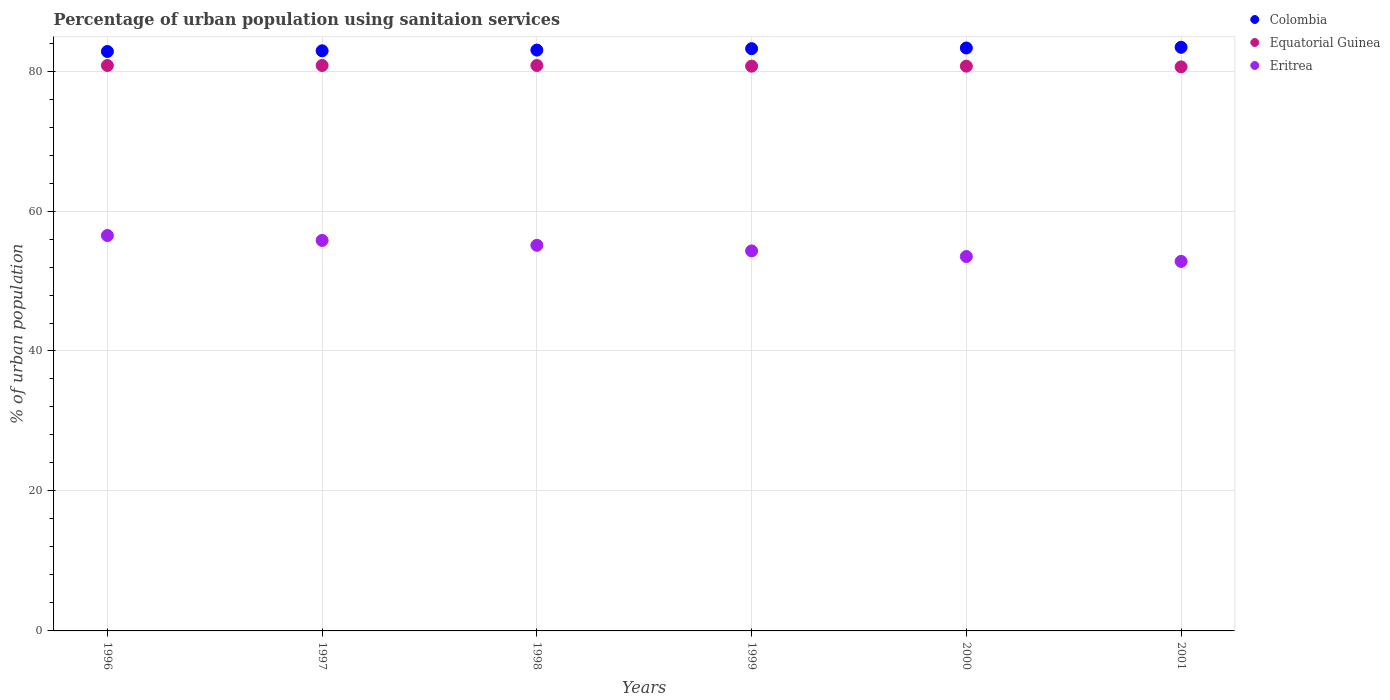How many different coloured dotlines are there?
Offer a terse response. 3. What is the percentage of urban population using sanitaion services in Eritrea in 1998?
Provide a short and direct response. 55.1. Across all years, what is the maximum percentage of urban population using sanitaion services in Eritrea?
Make the answer very short. 56.5. Across all years, what is the minimum percentage of urban population using sanitaion services in Eritrea?
Your response must be concise. 52.8. In which year was the percentage of urban population using sanitaion services in Equatorial Guinea maximum?
Make the answer very short. 1996. What is the total percentage of urban population using sanitaion services in Equatorial Guinea in the graph?
Make the answer very short. 484.4. What is the difference between the percentage of urban population using sanitaion services in Colombia in 1998 and that in 2001?
Give a very brief answer. -0.4. What is the difference between the percentage of urban population using sanitaion services in Equatorial Guinea in 1998 and the percentage of urban population using sanitaion services in Eritrea in 1996?
Your answer should be compact. 24.3. What is the average percentage of urban population using sanitaion services in Equatorial Guinea per year?
Your response must be concise. 80.73. In the year 1998, what is the difference between the percentage of urban population using sanitaion services in Equatorial Guinea and percentage of urban population using sanitaion services in Colombia?
Provide a short and direct response. -2.2. In how many years, is the percentage of urban population using sanitaion services in Colombia greater than 64 %?
Offer a very short reply. 6. What is the ratio of the percentage of urban population using sanitaion services in Colombia in 1996 to that in 2001?
Your answer should be compact. 0.99. What is the difference between the highest and the second highest percentage of urban population using sanitaion services in Eritrea?
Provide a succinct answer. 0.7. What is the difference between the highest and the lowest percentage of urban population using sanitaion services in Equatorial Guinea?
Ensure brevity in your answer.  0.2. In how many years, is the percentage of urban population using sanitaion services in Colombia greater than the average percentage of urban population using sanitaion services in Colombia taken over all years?
Provide a succinct answer. 3. Is the sum of the percentage of urban population using sanitaion services in Colombia in 1998 and 1999 greater than the maximum percentage of urban population using sanitaion services in Equatorial Guinea across all years?
Ensure brevity in your answer.  Yes. Is the percentage of urban population using sanitaion services in Colombia strictly greater than the percentage of urban population using sanitaion services in Eritrea over the years?
Offer a very short reply. Yes. How many dotlines are there?
Your answer should be compact. 3. What is the difference between two consecutive major ticks on the Y-axis?
Provide a succinct answer. 20. Does the graph contain any zero values?
Provide a short and direct response. No. Does the graph contain grids?
Ensure brevity in your answer.  Yes. Where does the legend appear in the graph?
Offer a terse response. Top right. How many legend labels are there?
Make the answer very short. 3. How are the legend labels stacked?
Offer a terse response. Vertical. What is the title of the graph?
Offer a terse response. Percentage of urban population using sanitaion services. Does "Timor-Leste" appear as one of the legend labels in the graph?
Provide a short and direct response. No. What is the label or title of the Y-axis?
Offer a terse response. % of urban population. What is the % of urban population of Colombia in 1996?
Make the answer very short. 82.8. What is the % of urban population in Equatorial Guinea in 1996?
Keep it short and to the point. 80.8. What is the % of urban population of Eritrea in 1996?
Keep it short and to the point. 56.5. What is the % of urban population in Colombia in 1997?
Keep it short and to the point. 82.9. What is the % of urban population of Equatorial Guinea in 1997?
Your answer should be very brief. 80.8. What is the % of urban population in Eritrea in 1997?
Your response must be concise. 55.8. What is the % of urban population of Colombia in 1998?
Ensure brevity in your answer.  83. What is the % of urban population of Equatorial Guinea in 1998?
Your answer should be very brief. 80.8. What is the % of urban population in Eritrea in 1998?
Your answer should be compact. 55.1. What is the % of urban population of Colombia in 1999?
Your answer should be compact. 83.2. What is the % of urban population in Equatorial Guinea in 1999?
Your answer should be very brief. 80.7. What is the % of urban population of Eritrea in 1999?
Provide a short and direct response. 54.3. What is the % of urban population in Colombia in 2000?
Provide a succinct answer. 83.3. What is the % of urban population in Equatorial Guinea in 2000?
Offer a very short reply. 80.7. What is the % of urban population of Eritrea in 2000?
Keep it short and to the point. 53.5. What is the % of urban population in Colombia in 2001?
Keep it short and to the point. 83.4. What is the % of urban population of Equatorial Guinea in 2001?
Ensure brevity in your answer.  80.6. What is the % of urban population in Eritrea in 2001?
Provide a short and direct response. 52.8. Across all years, what is the maximum % of urban population in Colombia?
Your response must be concise. 83.4. Across all years, what is the maximum % of urban population of Equatorial Guinea?
Provide a succinct answer. 80.8. Across all years, what is the maximum % of urban population in Eritrea?
Provide a succinct answer. 56.5. Across all years, what is the minimum % of urban population in Colombia?
Offer a terse response. 82.8. Across all years, what is the minimum % of urban population of Equatorial Guinea?
Offer a very short reply. 80.6. Across all years, what is the minimum % of urban population in Eritrea?
Make the answer very short. 52.8. What is the total % of urban population in Colombia in the graph?
Provide a short and direct response. 498.6. What is the total % of urban population of Equatorial Guinea in the graph?
Make the answer very short. 484.4. What is the total % of urban population of Eritrea in the graph?
Provide a succinct answer. 328. What is the difference between the % of urban population in Equatorial Guinea in 1996 and that in 1999?
Your answer should be very brief. 0.1. What is the difference between the % of urban population in Eritrea in 1996 and that in 1999?
Ensure brevity in your answer.  2.2. What is the difference between the % of urban population of Equatorial Guinea in 1996 and that in 2001?
Your response must be concise. 0.2. What is the difference between the % of urban population of Equatorial Guinea in 1997 and that in 1998?
Ensure brevity in your answer.  0. What is the difference between the % of urban population of Eritrea in 1997 and that in 1998?
Your answer should be very brief. 0.7. What is the difference between the % of urban population of Colombia in 1997 and that in 1999?
Provide a short and direct response. -0.3. What is the difference between the % of urban population in Colombia in 1997 and that in 2000?
Provide a short and direct response. -0.4. What is the difference between the % of urban population in Eritrea in 1997 and that in 2000?
Ensure brevity in your answer.  2.3. What is the difference between the % of urban population of Equatorial Guinea in 1997 and that in 2001?
Your answer should be compact. 0.2. What is the difference between the % of urban population in Eritrea in 1997 and that in 2001?
Your answer should be compact. 3. What is the difference between the % of urban population of Colombia in 1998 and that in 1999?
Your answer should be compact. -0.2. What is the difference between the % of urban population of Eritrea in 1998 and that in 1999?
Your answer should be very brief. 0.8. What is the difference between the % of urban population in Colombia in 1999 and that in 2000?
Your answer should be very brief. -0.1. What is the difference between the % of urban population in Equatorial Guinea in 1999 and that in 2001?
Your answer should be very brief. 0.1. What is the difference between the % of urban population of Eritrea in 1999 and that in 2001?
Your answer should be very brief. 1.5. What is the difference between the % of urban population of Eritrea in 2000 and that in 2001?
Your response must be concise. 0.7. What is the difference between the % of urban population of Colombia in 1996 and the % of urban population of Equatorial Guinea in 1997?
Make the answer very short. 2. What is the difference between the % of urban population in Colombia in 1996 and the % of urban population in Eritrea in 1998?
Make the answer very short. 27.7. What is the difference between the % of urban population in Equatorial Guinea in 1996 and the % of urban population in Eritrea in 1998?
Your response must be concise. 25.7. What is the difference between the % of urban population of Colombia in 1996 and the % of urban population of Eritrea in 1999?
Offer a terse response. 28.5. What is the difference between the % of urban population of Colombia in 1996 and the % of urban population of Eritrea in 2000?
Your response must be concise. 29.3. What is the difference between the % of urban population of Equatorial Guinea in 1996 and the % of urban population of Eritrea in 2000?
Provide a succinct answer. 27.3. What is the difference between the % of urban population of Colombia in 1996 and the % of urban population of Equatorial Guinea in 2001?
Give a very brief answer. 2.2. What is the difference between the % of urban population of Colombia in 1996 and the % of urban population of Eritrea in 2001?
Your response must be concise. 30. What is the difference between the % of urban population of Colombia in 1997 and the % of urban population of Eritrea in 1998?
Ensure brevity in your answer.  27.8. What is the difference between the % of urban population in Equatorial Guinea in 1997 and the % of urban population in Eritrea in 1998?
Ensure brevity in your answer.  25.7. What is the difference between the % of urban population of Colombia in 1997 and the % of urban population of Eritrea in 1999?
Make the answer very short. 28.6. What is the difference between the % of urban population of Equatorial Guinea in 1997 and the % of urban population of Eritrea in 1999?
Provide a succinct answer. 26.5. What is the difference between the % of urban population in Colombia in 1997 and the % of urban population in Equatorial Guinea in 2000?
Give a very brief answer. 2.2. What is the difference between the % of urban population of Colombia in 1997 and the % of urban population of Eritrea in 2000?
Keep it short and to the point. 29.4. What is the difference between the % of urban population in Equatorial Guinea in 1997 and the % of urban population in Eritrea in 2000?
Your response must be concise. 27.3. What is the difference between the % of urban population in Colombia in 1997 and the % of urban population in Equatorial Guinea in 2001?
Provide a succinct answer. 2.3. What is the difference between the % of urban population of Colombia in 1997 and the % of urban population of Eritrea in 2001?
Ensure brevity in your answer.  30.1. What is the difference between the % of urban population of Colombia in 1998 and the % of urban population of Equatorial Guinea in 1999?
Your response must be concise. 2.3. What is the difference between the % of urban population in Colombia in 1998 and the % of urban population in Eritrea in 1999?
Give a very brief answer. 28.7. What is the difference between the % of urban population in Equatorial Guinea in 1998 and the % of urban population in Eritrea in 1999?
Provide a succinct answer. 26.5. What is the difference between the % of urban population in Colombia in 1998 and the % of urban population in Eritrea in 2000?
Give a very brief answer. 29.5. What is the difference between the % of urban population of Equatorial Guinea in 1998 and the % of urban population of Eritrea in 2000?
Provide a succinct answer. 27.3. What is the difference between the % of urban population of Colombia in 1998 and the % of urban population of Eritrea in 2001?
Your answer should be very brief. 30.2. What is the difference between the % of urban population in Colombia in 1999 and the % of urban population in Equatorial Guinea in 2000?
Make the answer very short. 2.5. What is the difference between the % of urban population of Colombia in 1999 and the % of urban population of Eritrea in 2000?
Offer a terse response. 29.7. What is the difference between the % of urban population in Equatorial Guinea in 1999 and the % of urban population in Eritrea in 2000?
Your answer should be very brief. 27.2. What is the difference between the % of urban population of Colombia in 1999 and the % of urban population of Eritrea in 2001?
Provide a short and direct response. 30.4. What is the difference between the % of urban population of Equatorial Guinea in 1999 and the % of urban population of Eritrea in 2001?
Provide a short and direct response. 27.9. What is the difference between the % of urban population in Colombia in 2000 and the % of urban population in Equatorial Guinea in 2001?
Give a very brief answer. 2.7. What is the difference between the % of urban population in Colombia in 2000 and the % of urban population in Eritrea in 2001?
Offer a very short reply. 30.5. What is the difference between the % of urban population in Equatorial Guinea in 2000 and the % of urban population in Eritrea in 2001?
Your response must be concise. 27.9. What is the average % of urban population in Colombia per year?
Ensure brevity in your answer.  83.1. What is the average % of urban population of Equatorial Guinea per year?
Offer a terse response. 80.73. What is the average % of urban population of Eritrea per year?
Your answer should be compact. 54.67. In the year 1996, what is the difference between the % of urban population of Colombia and % of urban population of Eritrea?
Give a very brief answer. 26.3. In the year 1996, what is the difference between the % of urban population in Equatorial Guinea and % of urban population in Eritrea?
Ensure brevity in your answer.  24.3. In the year 1997, what is the difference between the % of urban population of Colombia and % of urban population of Equatorial Guinea?
Ensure brevity in your answer.  2.1. In the year 1997, what is the difference between the % of urban population of Colombia and % of urban population of Eritrea?
Make the answer very short. 27.1. In the year 1998, what is the difference between the % of urban population in Colombia and % of urban population in Equatorial Guinea?
Provide a succinct answer. 2.2. In the year 1998, what is the difference between the % of urban population of Colombia and % of urban population of Eritrea?
Offer a very short reply. 27.9. In the year 1998, what is the difference between the % of urban population in Equatorial Guinea and % of urban population in Eritrea?
Offer a terse response. 25.7. In the year 1999, what is the difference between the % of urban population of Colombia and % of urban population of Eritrea?
Your answer should be very brief. 28.9. In the year 1999, what is the difference between the % of urban population in Equatorial Guinea and % of urban population in Eritrea?
Your response must be concise. 26.4. In the year 2000, what is the difference between the % of urban population of Colombia and % of urban population of Eritrea?
Your answer should be very brief. 29.8. In the year 2000, what is the difference between the % of urban population of Equatorial Guinea and % of urban population of Eritrea?
Your answer should be compact. 27.2. In the year 2001, what is the difference between the % of urban population in Colombia and % of urban population in Equatorial Guinea?
Your response must be concise. 2.8. In the year 2001, what is the difference between the % of urban population in Colombia and % of urban population in Eritrea?
Offer a terse response. 30.6. In the year 2001, what is the difference between the % of urban population of Equatorial Guinea and % of urban population of Eritrea?
Your answer should be very brief. 27.8. What is the ratio of the % of urban population in Colombia in 1996 to that in 1997?
Give a very brief answer. 1. What is the ratio of the % of urban population in Eritrea in 1996 to that in 1997?
Your response must be concise. 1.01. What is the ratio of the % of urban population in Equatorial Guinea in 1996 to that in 1998?
Provide a succinct answer. 1. What is the ratio of the % of urban population in Eritrea in 1996 to that in 1998?
Offer a very short reply. 1.03. What is the ratio of the % of urban population in Equatorial Guinea in 1996 to that in 1999?
Offer a terse response. 1. What is the ratio of the % of urban population of Eritrea in 1996 to that in 1999?
Provide a succinct answer. 1.04. What is the ratio of the % of urban population in Colombia in 1996 to that in 2000?
Make the answer very short. 0.99. What is the ratio of the % of urban population of Equatorial Guinea in 1996 to that in 2000?
Your answer should be compact. 1. What is the ratio of the % of urban population in Eritrea in 1996 to that in 2000?
Give a very brief answer. 1.06. What is the ratio of the % of urban population of Colombia in 1996 to that in 2001?
Give a very brief answer. 0.99. What is the ratio of the % of urban population in Equatorial Guinea in 1996 to that in 2001?
Give a very brief answer. 1. What is the ratio of the % of urban population in Eritrea in 1996 to that in 2001?
Your response must be concise. 1.07. What is the ratio of the % of urban population of Colombia in 1997 to that in 1998?
Keep it short and to the point. 1. What is the ratio of the % of urban population in Eritrea in 1997 to that in 1998?
Provide a short and direct response. 1.01. What is the ratio of the % of urban population of Eritrea in 1997 to that in 1999?
Make the answer very short. 1.03. What is the ratio of the % of urban population in Colombia in 1997 to that in 2000?
Give a very brief answer. 1. What is the ratio of the % of urban population of Equatorial Guinea in 1997 to that in 2000?
Your answer should be very brief. 1. What is the ratio of the % of urban population of Eritrea in 1997 to that in 2000?
Ensure brevity in your answer.  1.04. What is the ratio of the % of urban population of Colombia in 1997 to that in 2001?
Your answer should be compact. 0.99. What is the ratio of the % of urban population of Equatorial Guinea in 1997 to that in 2001?
Your answer should be compact. 1. What is the ratio of the % of urban population of Eritrea in 1997 to that in 2001?
Your answer should be compact. 1.06. What is the ratio of the % of urban population of Colombia in 1998 to that in 1999?
Ensure brevity in your answer.  1. What is the ratio of the % of urban population in Eritrea in 1998 to that in 1999?
Give a very brief answer. 1.01. What is the ratio of the % of urban population of Eritrea in 1998 to that in 2000?
Your answer should be very brief. 1.03. What is the ratio of the % of urban population of Colombia in 1998 to that in 2001?
Your answer should be compact. 1. What is the ratio of the % of urban population of Equatorial Guinea in 1998 to that in 2001?
Provide a short and direct response. 1. What is the ratio of the % of urban population of Eritrea in 1998 to that in 2001?
Your answer should be very brief. 1.04. What is the ratio of the % of urban population of Colombia in 1999 to that in 2000?
Your response must be concise. 1. What is the ratio of the % of urban population of Eritrea in 1999 to that in 2001?
Make the answer very short. 1.03. What is the ratio of the % of urban population in Equatorial Guinea in 2000 to that in 2001?
Your answer should be compact. 1. What is the ratio of the % of urban population in Eritrea in 2000 to that in 2001?
Your answer should be very brief. 1.01. What is the difference between the highest and the second highest % of urban population in Colombia?
Ensure brevity in your answer.  0.1. What is the difference between the highest and the second highest % of urban population of Equatorial Guinea?
Your response must be concise. 0. What is the difference between the highest and the lowest % of urban population of Eritrea?
Provide a succinct answer. 3.7. 